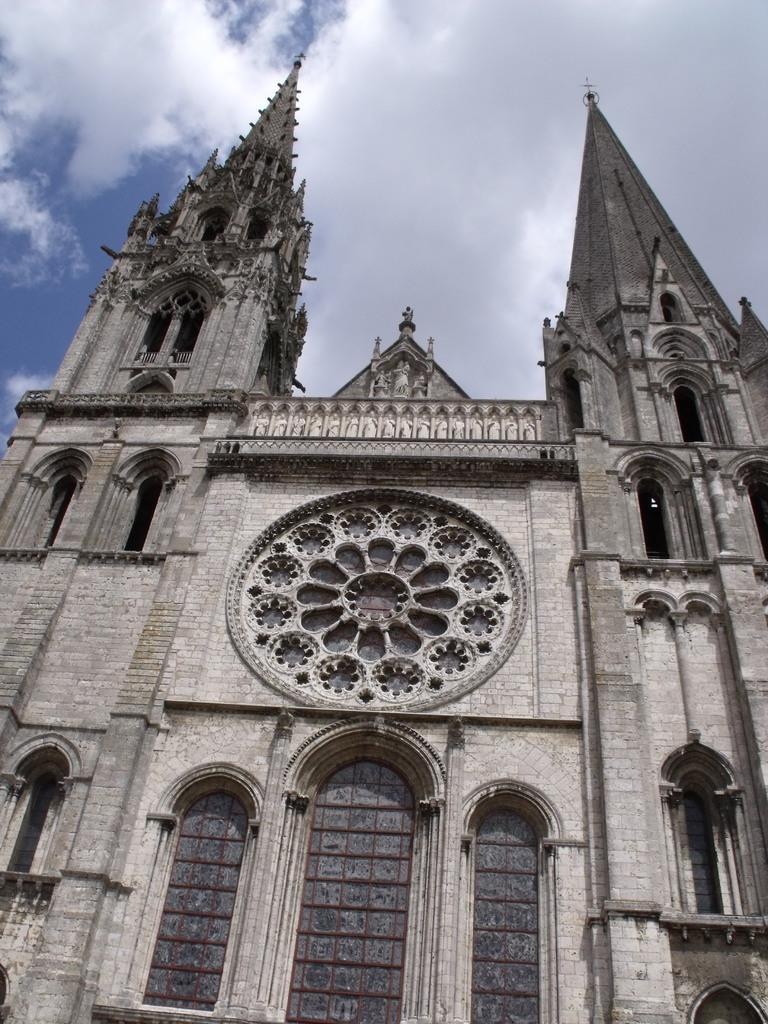Describe this image in one or two sentences. In this image I can see a building, windows, clouds and the sky. 